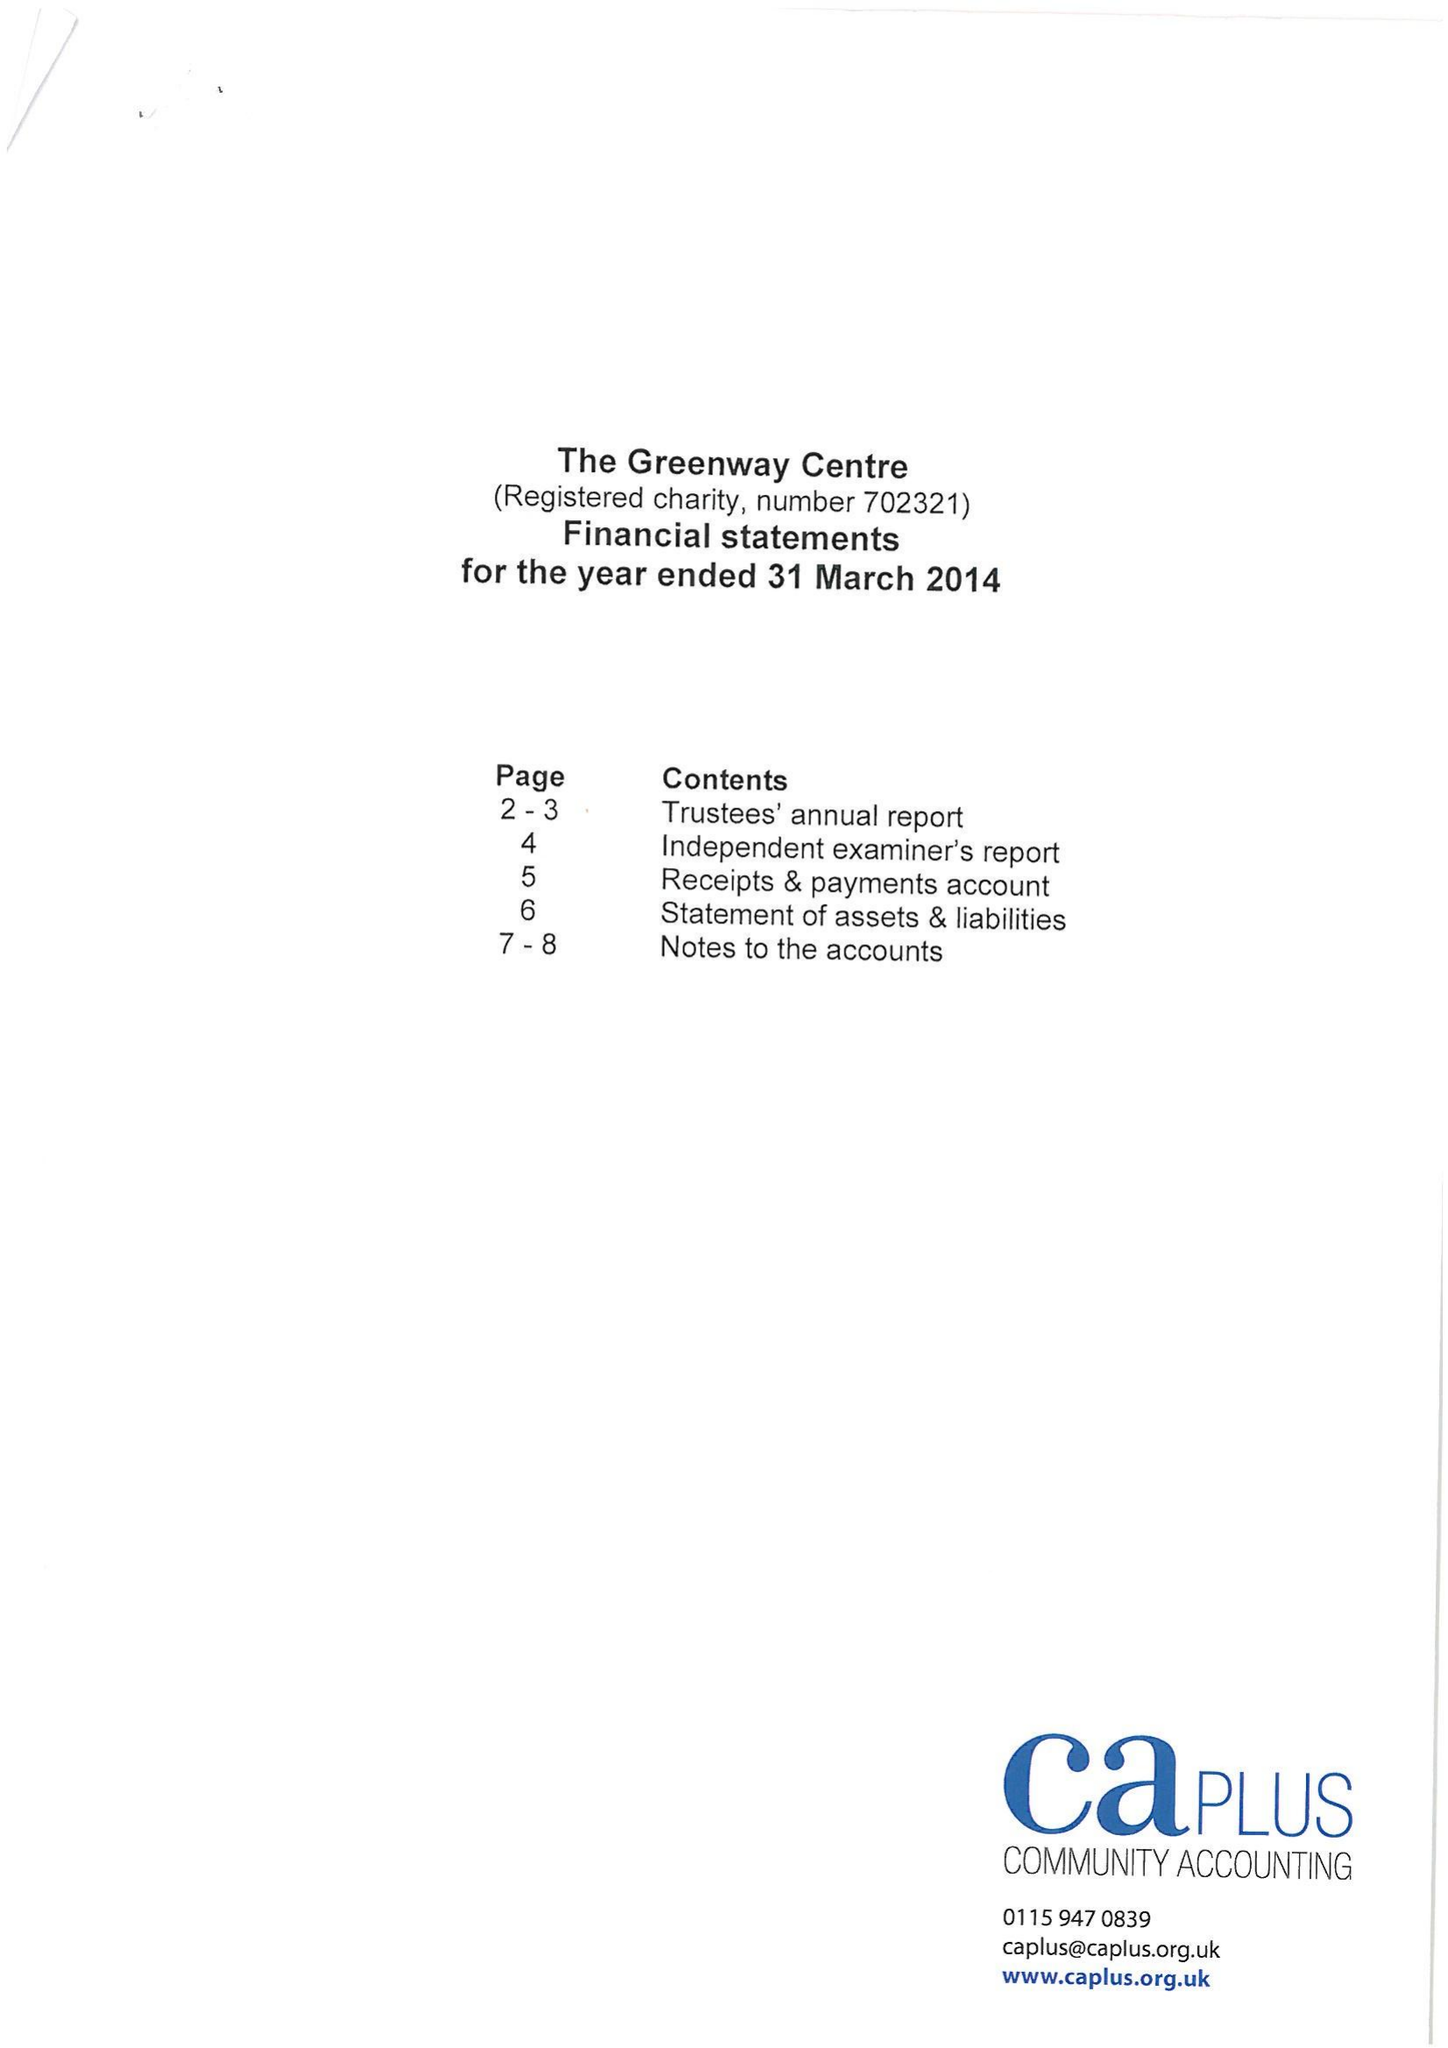What is the value for the address__post_town?
Answer the question using a single word or phrase. NOTTINGHAM 